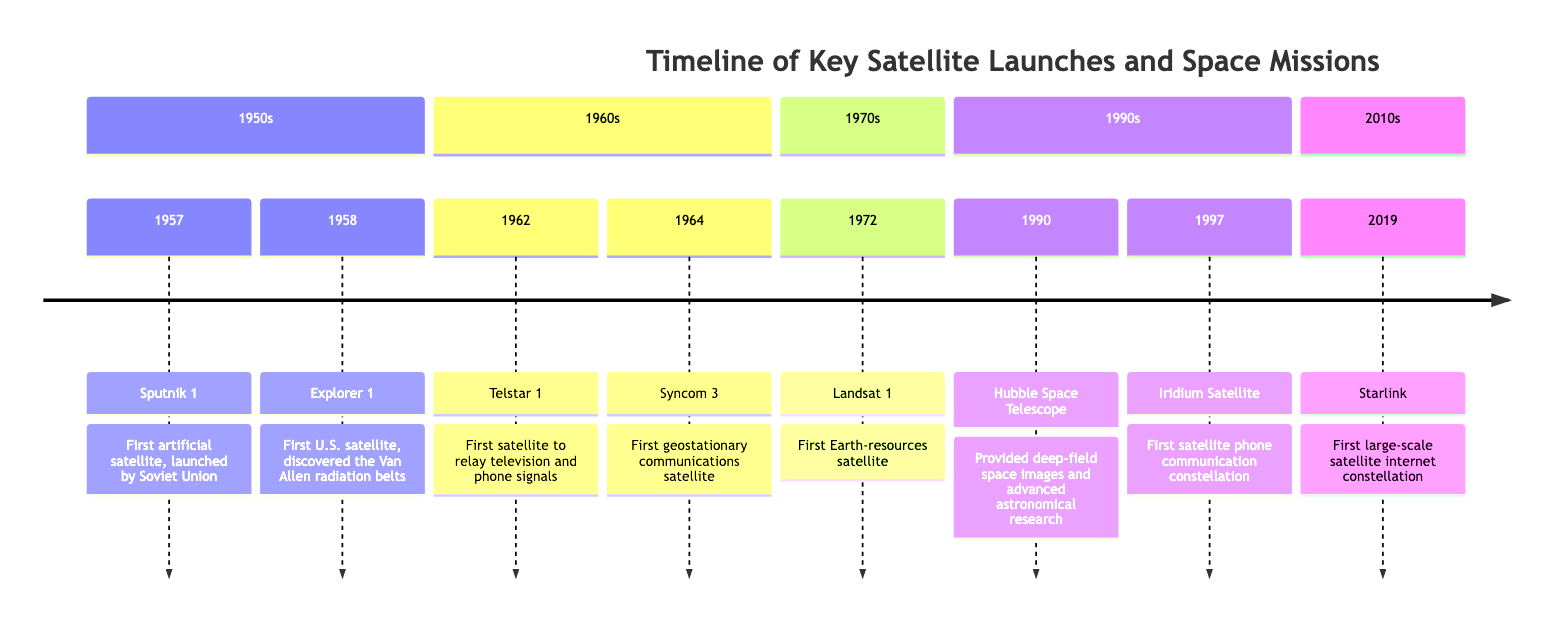What was the first artificial satellite launched? The diagram indicates that Sputnik 1 was the first artificial satellite, launched in 1957 by the Soviet Union.
Answer: Sputnik 1 Which satellite discovered the Van Allen radiation belts? According to the timeline, Explorer 1 was the first U.S. satellite that discovered the Van Allen radiation belts, launched in 1958.
Answer: Explorer 1 In what year was the first geostationary communications satellite launched? The timeline shows that the first geostationary communications satellite, Syncom 3, was launched in 1964.
Answer: 1964 How many satellites were launched in the 1970s? The diagram reveals that only one satellite, Landsat 1, was launched in the 1970s, indicating a total of one satellite for that decade.
Answer: 1 Which satellite was the first to relay television and phone signals? The diagram states that Telstar 1 was the first satellite to relay television and phone signals, launched in 1962.
Answer: Telstar 1 What major technological advancement occurred with Hubble Space Telescope? The diagram notes that the Hubble Space Telescope provided deep-field space images and advanced astronomical research, marking a significant technological innovation in the 1990s.
Answer: Deep-field space images What sequence of events occurred from 1957 to 1964 regarding satellite launches? The timeline shows that from 1957 to 1964, Sputnik 1 was launched first, followed by Explorer 1, then Telstar 1, and finally Syncom 3. This indicates a rapid advancement in satellite technology in this period.
Answer: Sputnik 1, Explorer 1, Telstar 1, Syncom 3 Which decade saw the launch of the first Earth-resources satellite? The timeline indicates that Landsat 1, the first Earth-resources satellite, was launched in the 1970s.
Answer: 1970s What is the significance of the Starlink satellite launched in 2019? The diagram highlights that Starlink was the first large-scale satellite internet constellation, marking a pivotal development in satellite technology and connectivity.
Answer: Satellite internet constellation 